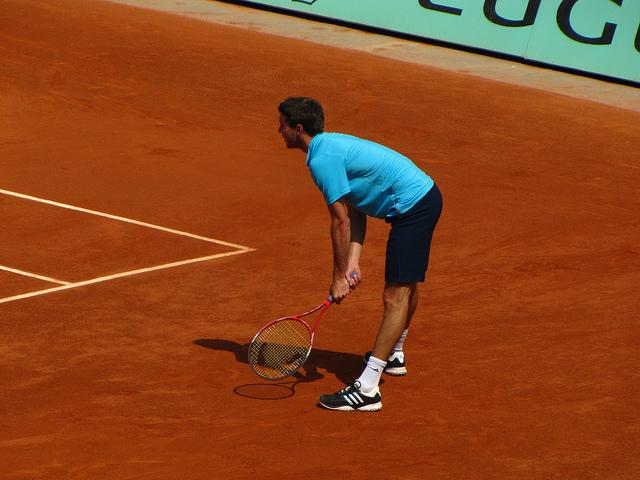Are there spectators?
Give a very brief answer. Yes. Is the man waiting for the ball?
Give a very brief answer. Yes. What is he holding?
Concise answer only. Tennis racket. How many people are wearing hats?
Answer briefly. 0. Is the guy alone in court?
Answer briefly. No. What is the man holding?
Quick response, please. Racket. What sport is this?
Answer briefly. Tennis. What sport is being played?
Write a very short answer. Tennis. What is the color of the shirt?
Keep it brief. Blue. Are his feet touching the ground?
Write a very short answer. Yes. What game are they playing?
Short answer required. Tennis. 